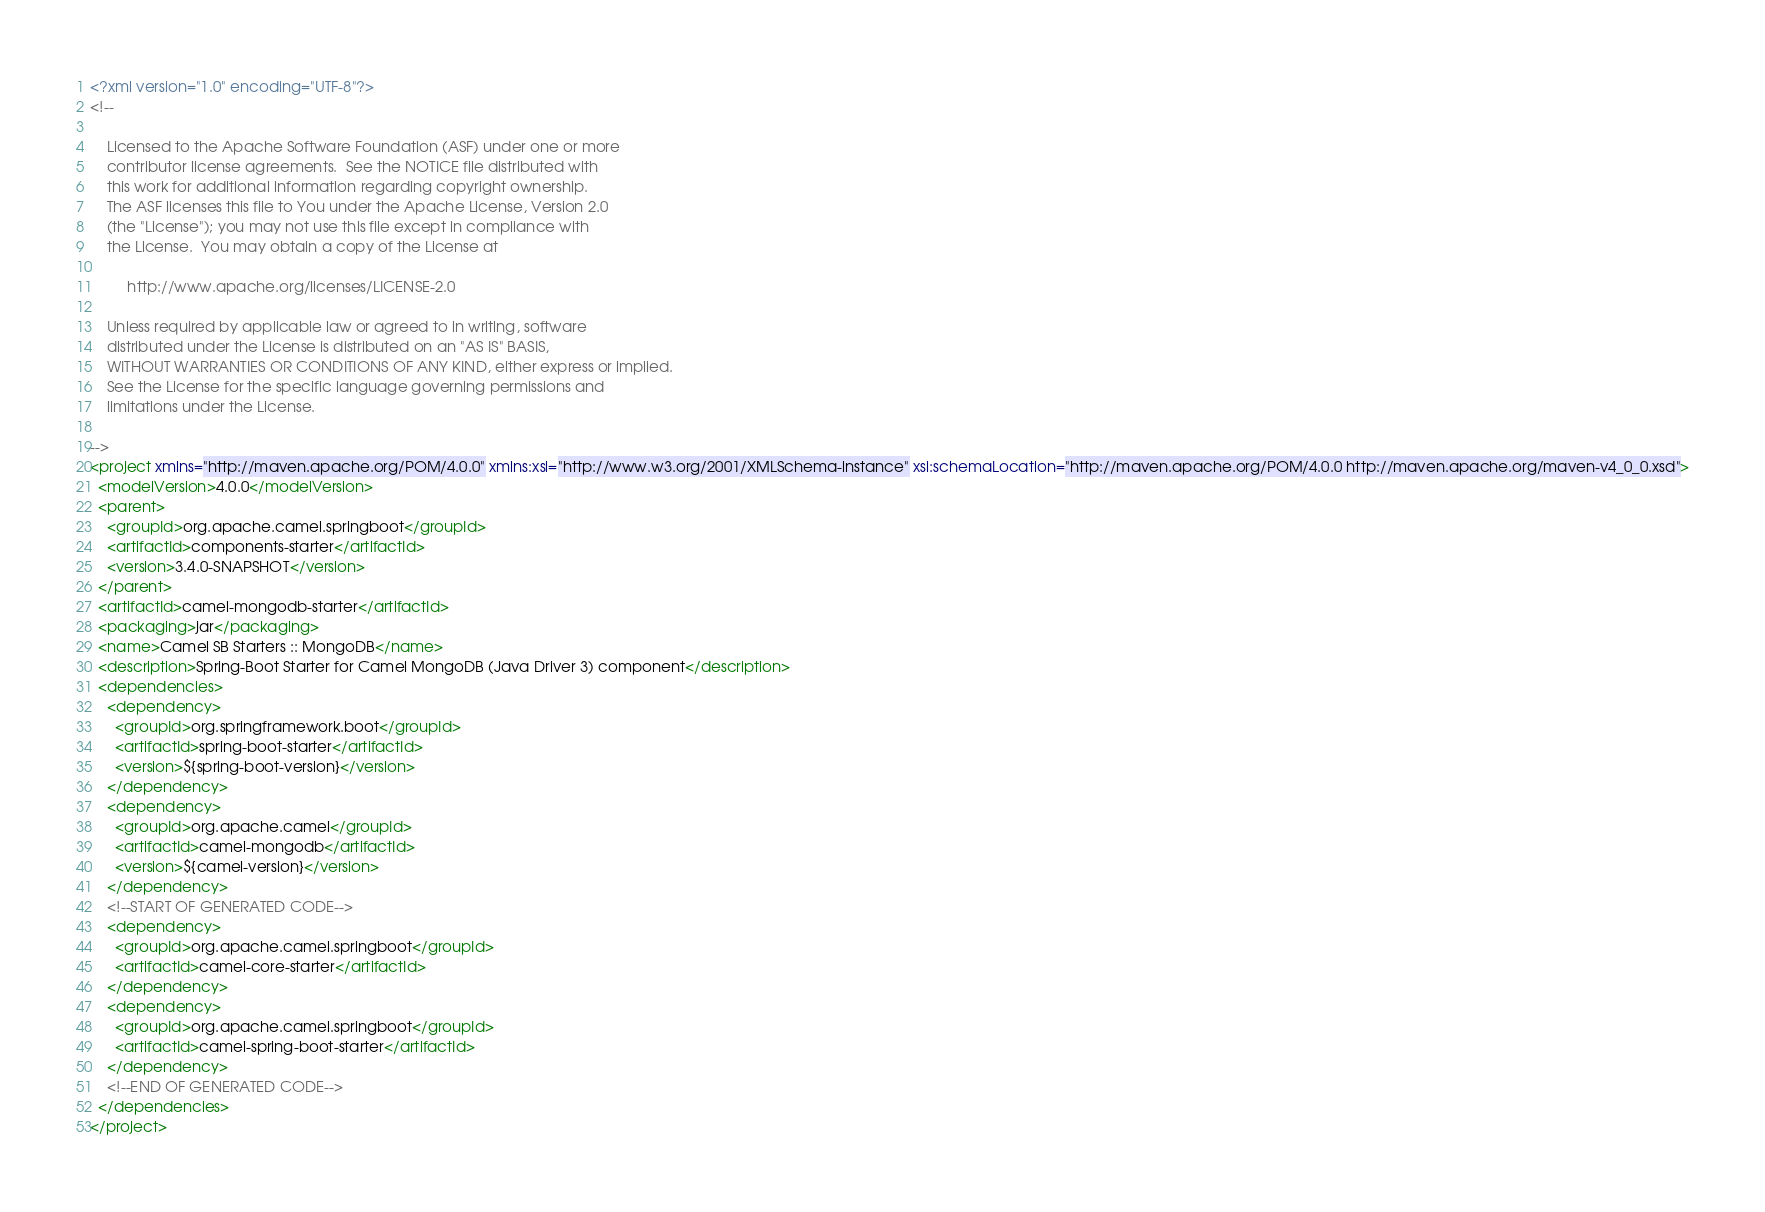<code> <loc_0><loc_0><loc_500><loc_500><_XML_><?xml version="1.0" encoding="UTF-8"?>
<!--

    Licensed to the Apache Software Foundation (ASF) under one or more
    contributor license agreements.  See the NOTICE file distributed with
    this work for additional information regarding copyright ownership.
    The ASF licenses this file to You under the Apache License, Version 2.0
    (the "License"); you may not use this file except in compliance with
    the License.  You may obtain a copy of the License at

         http://www.apache.org/licenses/LICENSE-2.0

    Unless required by applicable law or agreed to in writing, software
    distributed under the License is distributed on an "AS IS" BASIS,
    WITHOUT WARRANTIES OR CONDITIONS OF ANY KIND, either express or implied.
    See the License for the specific language governing permissions and
    limitations under the License.

-->
<project xmlns="http://maven.apache.org/POM/4.0.0" xmlns:xsi="http://www.w3.org/2001/XMLSchema-instance" xsi:schemaLocation="http://maven.apache.org/POM/4.0.0 http://maven.apache.org/maven-v4_0_0.xsd">
  <modelVersion>4.0.0</modelVersion>
  <parent>
    <groupId>org.apache.camel.springboot</groupId>
    <artifactId>components-starter</artifactId>
    <version>3.4.0-SNAPSHOT</version>
  </parent>
  <artifactId>camel-mongodb-starter</artifactId>
  <packaging>jar</packaging>
  <name>Camel SB Starters :: MongoDB</name>
  <description>Spring-Boot Starter for Camel MongoDB (Java Driver 3) component</description>
  <dependencies>
    <dependency>
      <groupId>org.springframework.boot</groupId>
      <artifactId>spring-boot-starter</artifactId>
      <version>${spring-boot-version}</version>
    </dependency>
    <dependency>
      <groupId>org.apache.camel</groupId>
      <artifactId>camel-mongodb</artifactId>
      <version>${camel-version}</version>
    </dependency>
    <!--START OF GENERATED CODE-->
    <dependency>
      <groupId>org.apache.camel.springboot</groupId>
      <artifactId>camel-core-starter</artifactId>
    </dependency>
    <dependency>
      <groupId>org.apache.camel.springboot</groupId>
      <artifactId>camel-spring-boot-starter</artifactId>
    </dependency>
    <!--END OF GENERATED CODE-->
  </dependencies>
</project>
</code> 